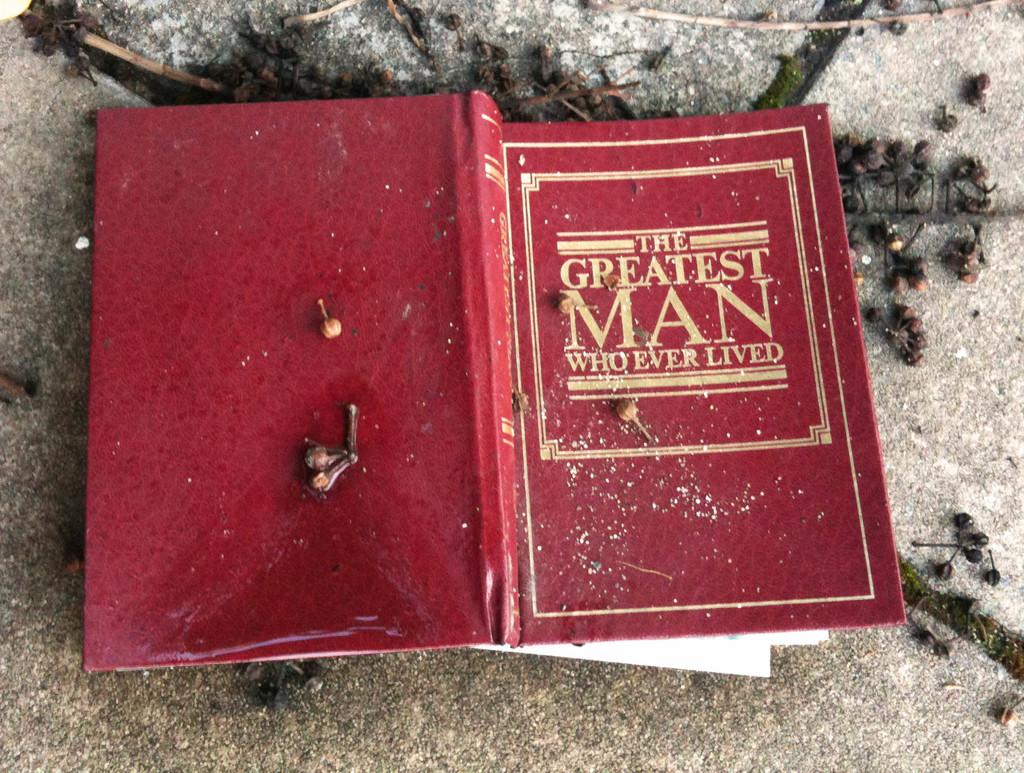What's the title of this book?
Your answer should be very brief. The greatest man who ever lived. 